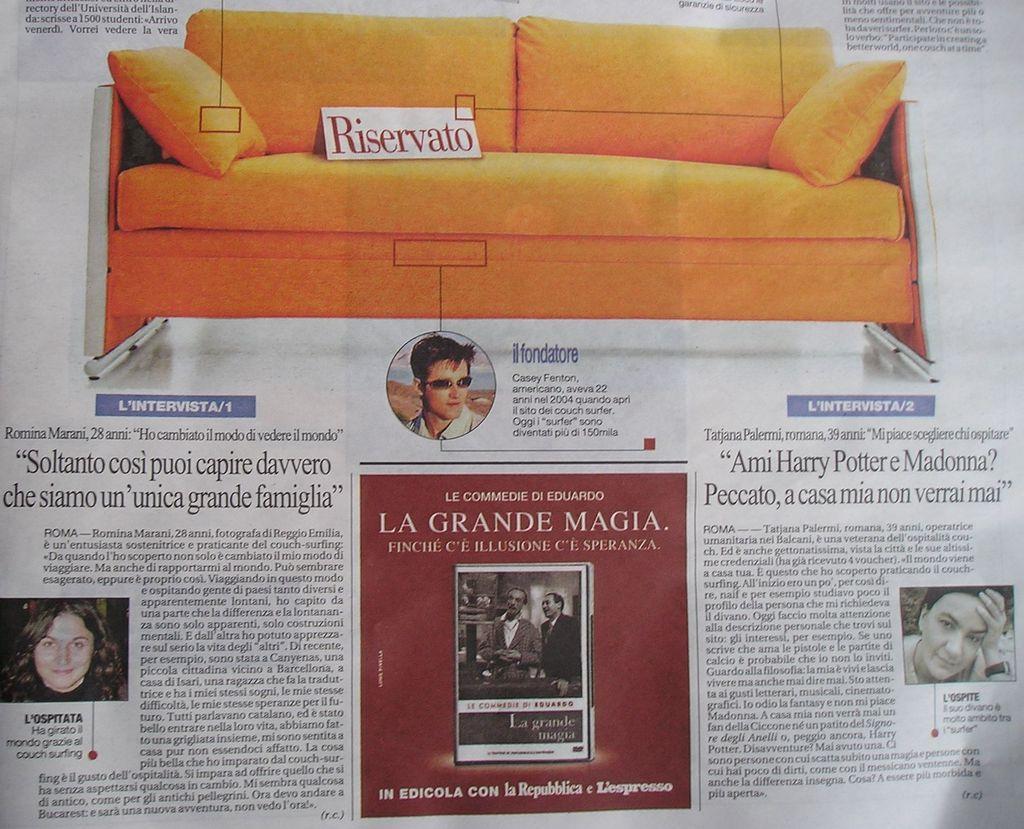Could you give a brief overview of what you see in this image? In the image I can see a paper in which there are some pictures of people, sofa and something written on it. 